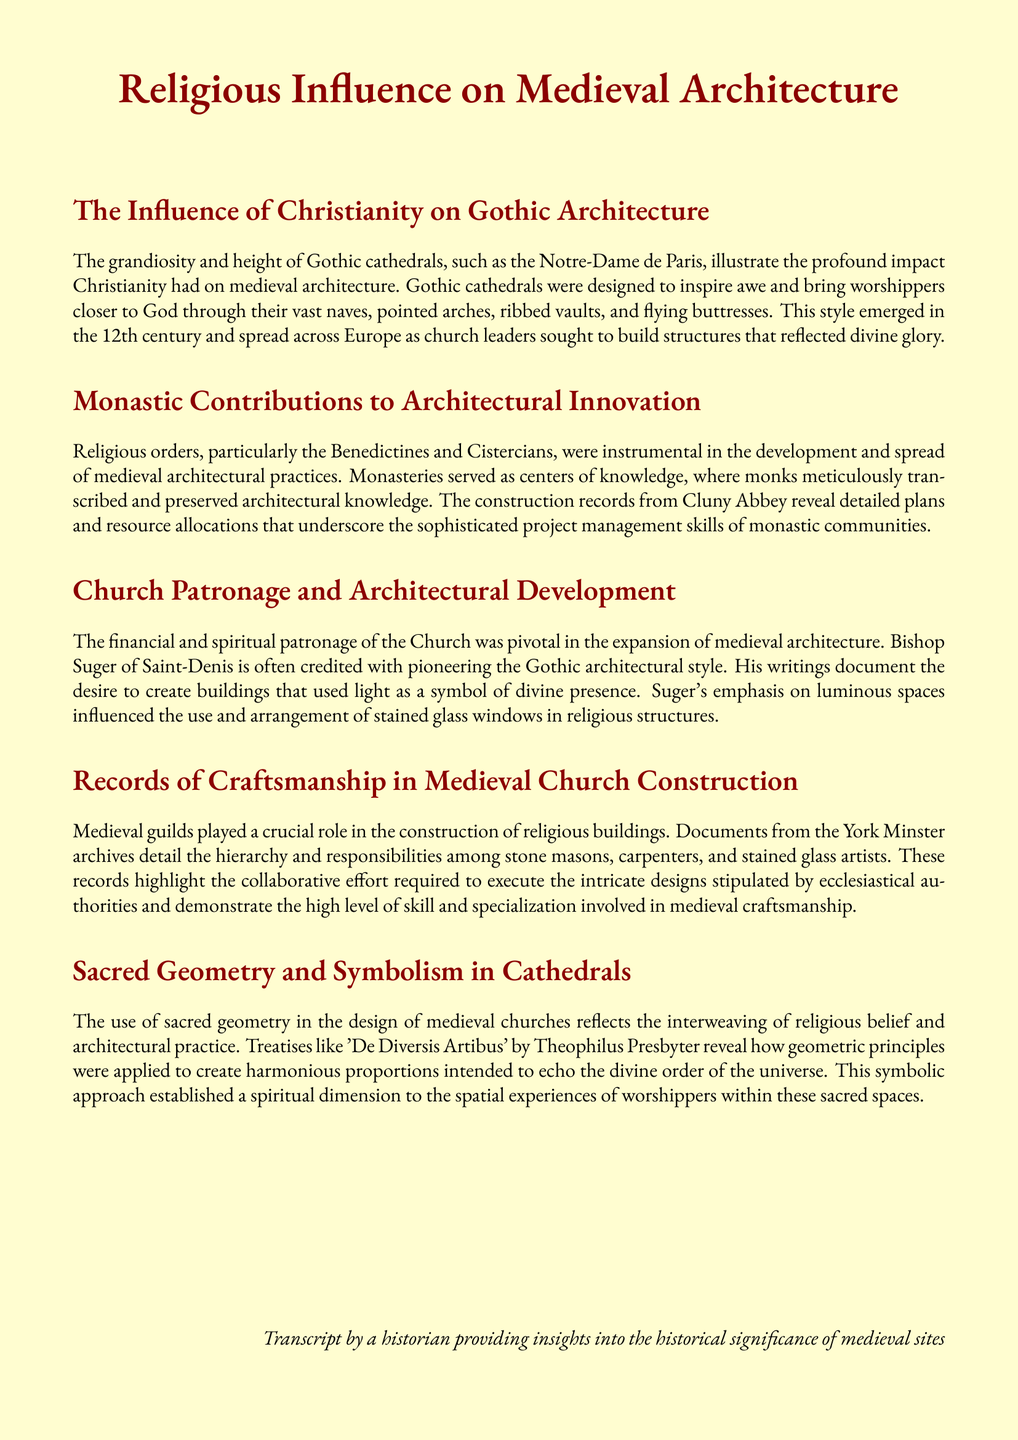What architectural style did Bishop Suger pioneer? Bishop Suger is credited with pioneering the Gothic architectural style.
Answer: Gothic Which two religious orders contributed to architectural innovation? The monastic orders mentioned that were instrumental in medieval architecture are the Benedictines and Cistercians.
Answer: Benedictines and Cistercians What is the primary goal of the design of Gothic cathedrals? The design of Gothic cathedrals aimed to inspire awe and bring worshippers closer to God.
Answer: Inspire awe What document discusses sacred geometry in medieval churches? The treatise that reveals the application of geometric principles in church design is 'De Diversis Artibus' by Theophilus Presbyter.
Answer: De Diversis Artibus What major architectural feature is associated with Gothic cathedrals? The major architectural features associated with Gothic cathedrals include vast naves, pointed arches, ribbed vaults, and flying buttresses.
Answer: Flying buttresses What symbol does Bishop Suger emphasize in his writings? Bishop Suger emphasizes light as a symbol of divine presence in his writings.
Answer: Light How did medieval guilds contribute to church construction? Medieval guilds played a crucial role by detailing the hierarchy and responsibilities of craftsmen involved in the construction of religious buildings.
Answer: Hierarchy and responsibilities What was the role of monasteries in medieval architecture? Monasteries served as centers of knowledge, where monks transcribed and preserved architectural knowledge.
Answer: Centers of knowledge 